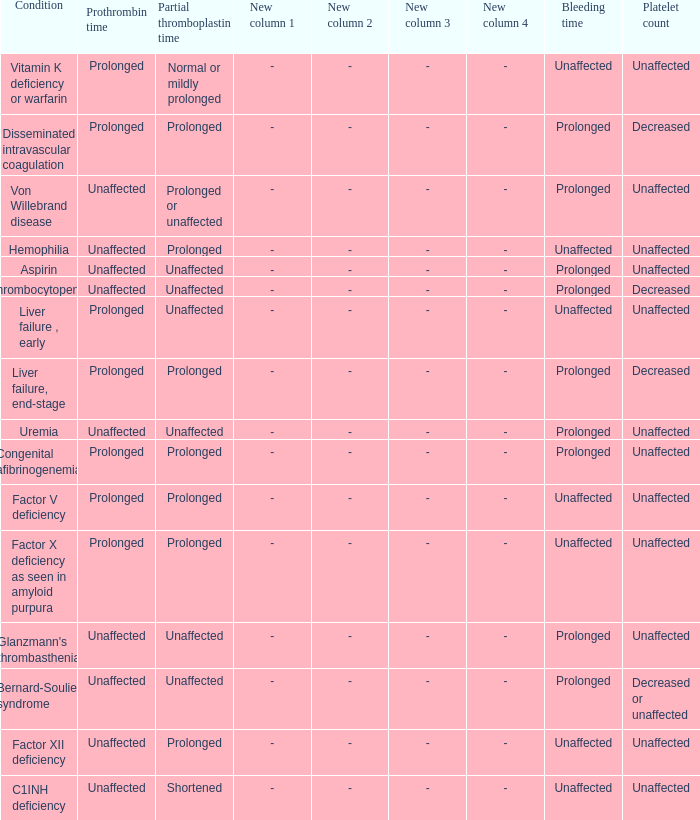Which Platelet count has a Condition of factor v deficiency? Unaffected. 